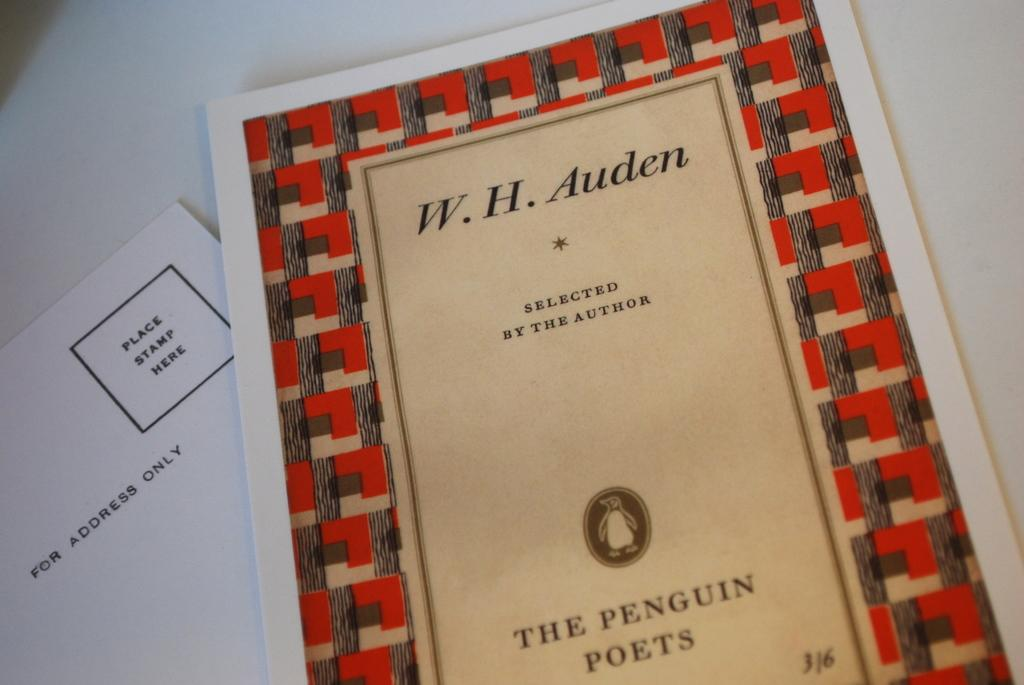<image>
Describe the image concisely. A book of poems selected by author W.H. Auden. 